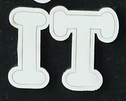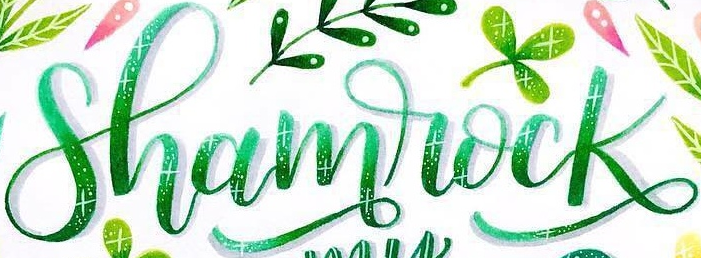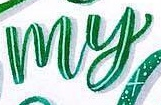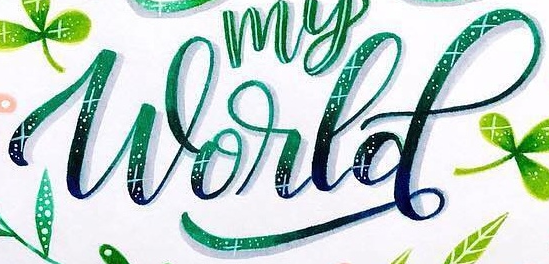Read the text content from these images in order, separated by a semicolon. IT; Shamrock; my; World 